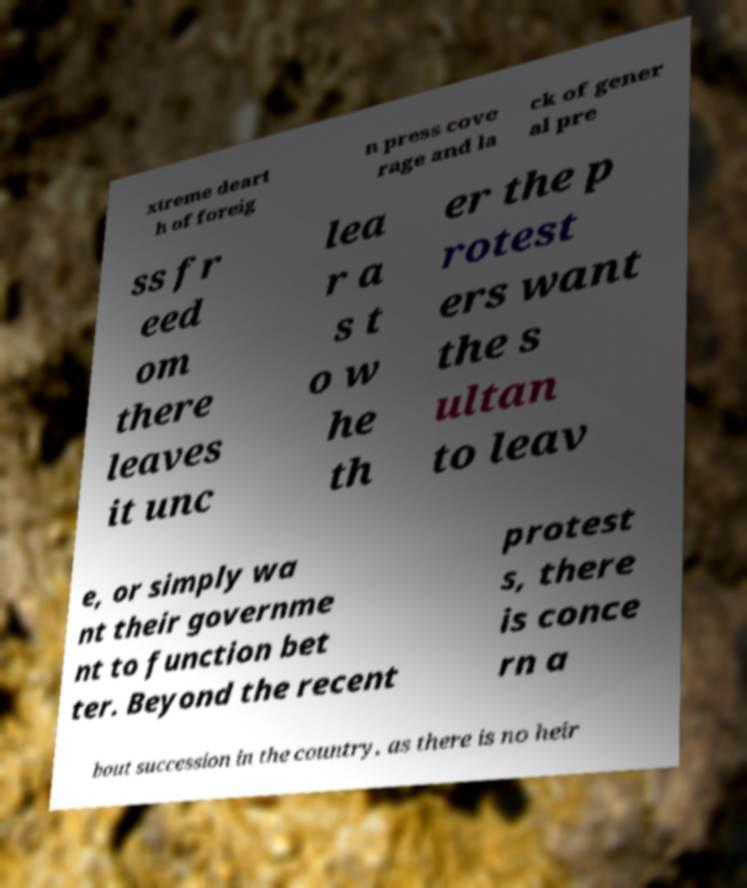Please read and relay the text visible in this image. What does it say? xtreme deart h of foreig n press cove rage and la ck of gener al pre ss fr eed om there leaves it unc lea r a s t o w he th er the p rotest ers want the s ultan to leav e, or simply wa nt their governme nt to function bet ter. Beyond the recent protest s, there is conce rn a bout succession in the country, as there is no heir 